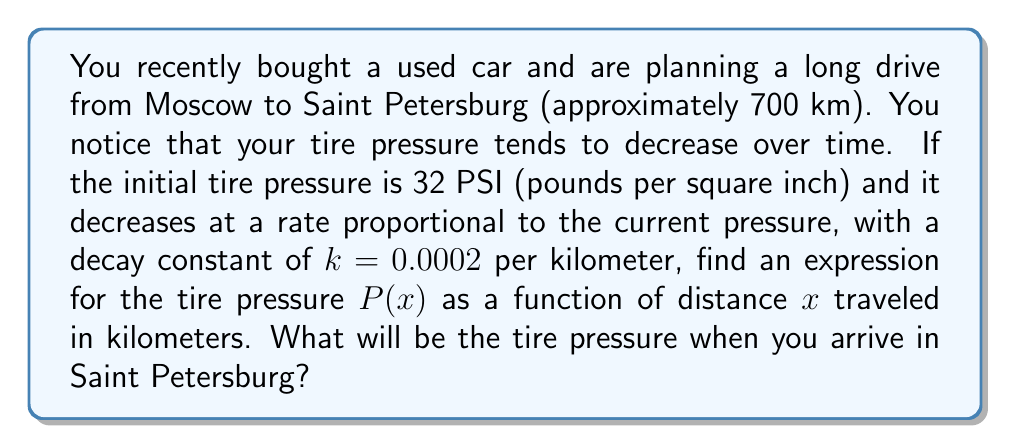Help me with this question. Let's approach this step-by-step:

1) The rate of change of pressure with respect to distance is proportional to the current pressure. This can be expressed as a differential equation:

   $$\frac{dP}{dx} = -kP$$

   Where $k = 0.0002$ per kilometer and the negative sign indicates a decrease in pressure.

2) This is a separable differential equation. We can solve it by separating variables:

   $$\frac{dP}{P} = -k dx$$

3) Integrating both sides:

   $$\int \frac{dP}{P} = -k \int dx$$

   $$\ln|P| = -kx + C$$

   Where $C$ is a constant of integration.

4) Exponentiating both sides:

   $$P = e^{-kx + C} = e^C \cdot e^{-kx}$$

5) Let $A = e^C$. Then our general solution is:

   $$P(x) = A e^{-kx}$$

6) To find $A$, we use the initial condition. At $x = 0$, $P = 32$ PSI:

   $$32 = A e^{-k(0)} = A$$

7) Therefore, our specific solution is:

   $$P(x) = 32 e^{-0.0002x}$$

8) To find the pressure at 700 km:

   $$P(700) = 32 e^{-0.0002(700)} \approx 27.54$$ PSI
Answer: The expression for tire pressure as a function of distance is $P(x) = 32 e^{-0.0002x}$ PSI, where $x$ is the distance in kilometers. The tire pressure upon arrival in Saint Petersburg (after 700 km) will be approximately 27.54 PSI. 